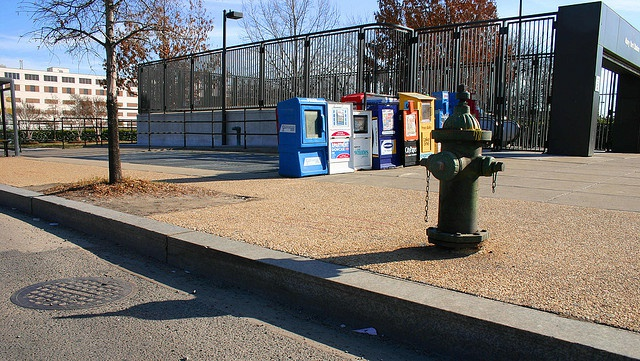Describe the objects in this image and their specific colors. I can see a fire hydrant in lightblue, black, gray, and darkgray tones in this image. 